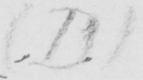Transcribe the text shown in this historical manuscript line. ( D ) 